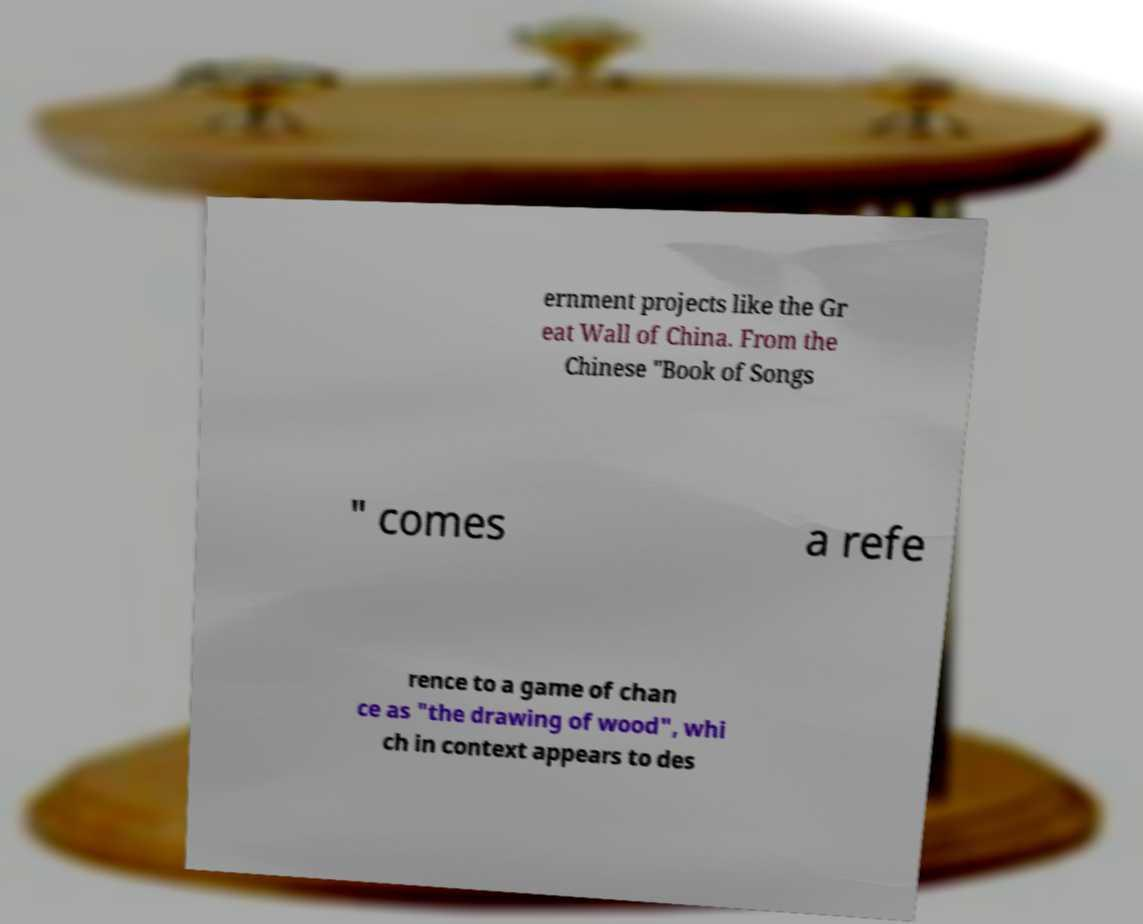Please read and relay the text visible in this image. What does it say? ernment projects like the Gr eat Wall of China. From the Chinese "Book of Songs " comes a refe rence to a game of chan ce as "the drawing of wood", whi ch in context appears to des 